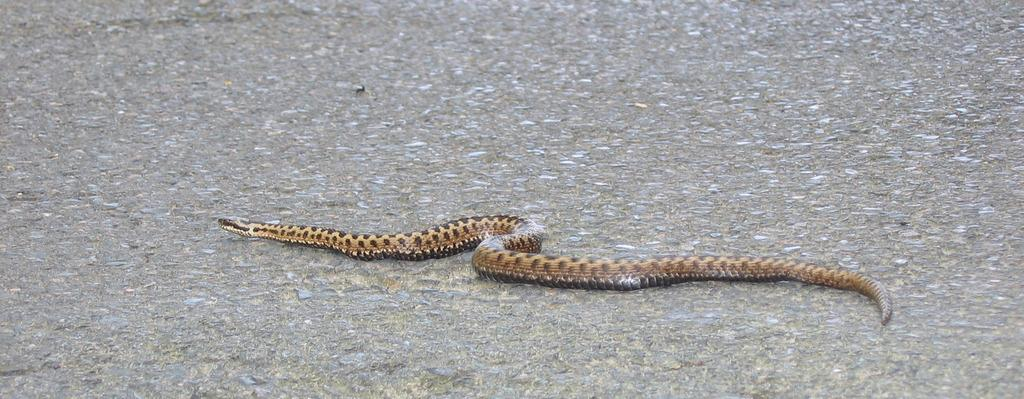What animal can be seen in the image? There is a snake in the image. Where is the snake located? The snake is on the road. What type of science experiment is being conducted with the cattle and icicles in the image? There is no cattle or icicles present in the image, and therefore no such experiment can be observed. 